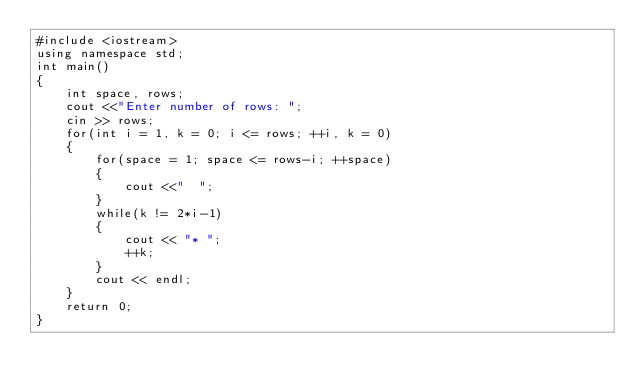<code> <loc_0><loc_0><loc_500><loc_500><_C++_>#include <iostream>
using namespace std;
int main()
{
    int space, rows;
    cout <<"Enter number of rows: ";
    cin >> rows;
    for(int i = 1, k = 0; i <= rows; ++i, k = 0)
    {
        for(space = 1; space <= rows-i; ++space)
        {
            cout <<"  ";
        }
        while(k != 2*i-1)
        {
            cout << "* ";
            ++k;
        }
        cout << endl;
    }    
    return 0;
}</code> 